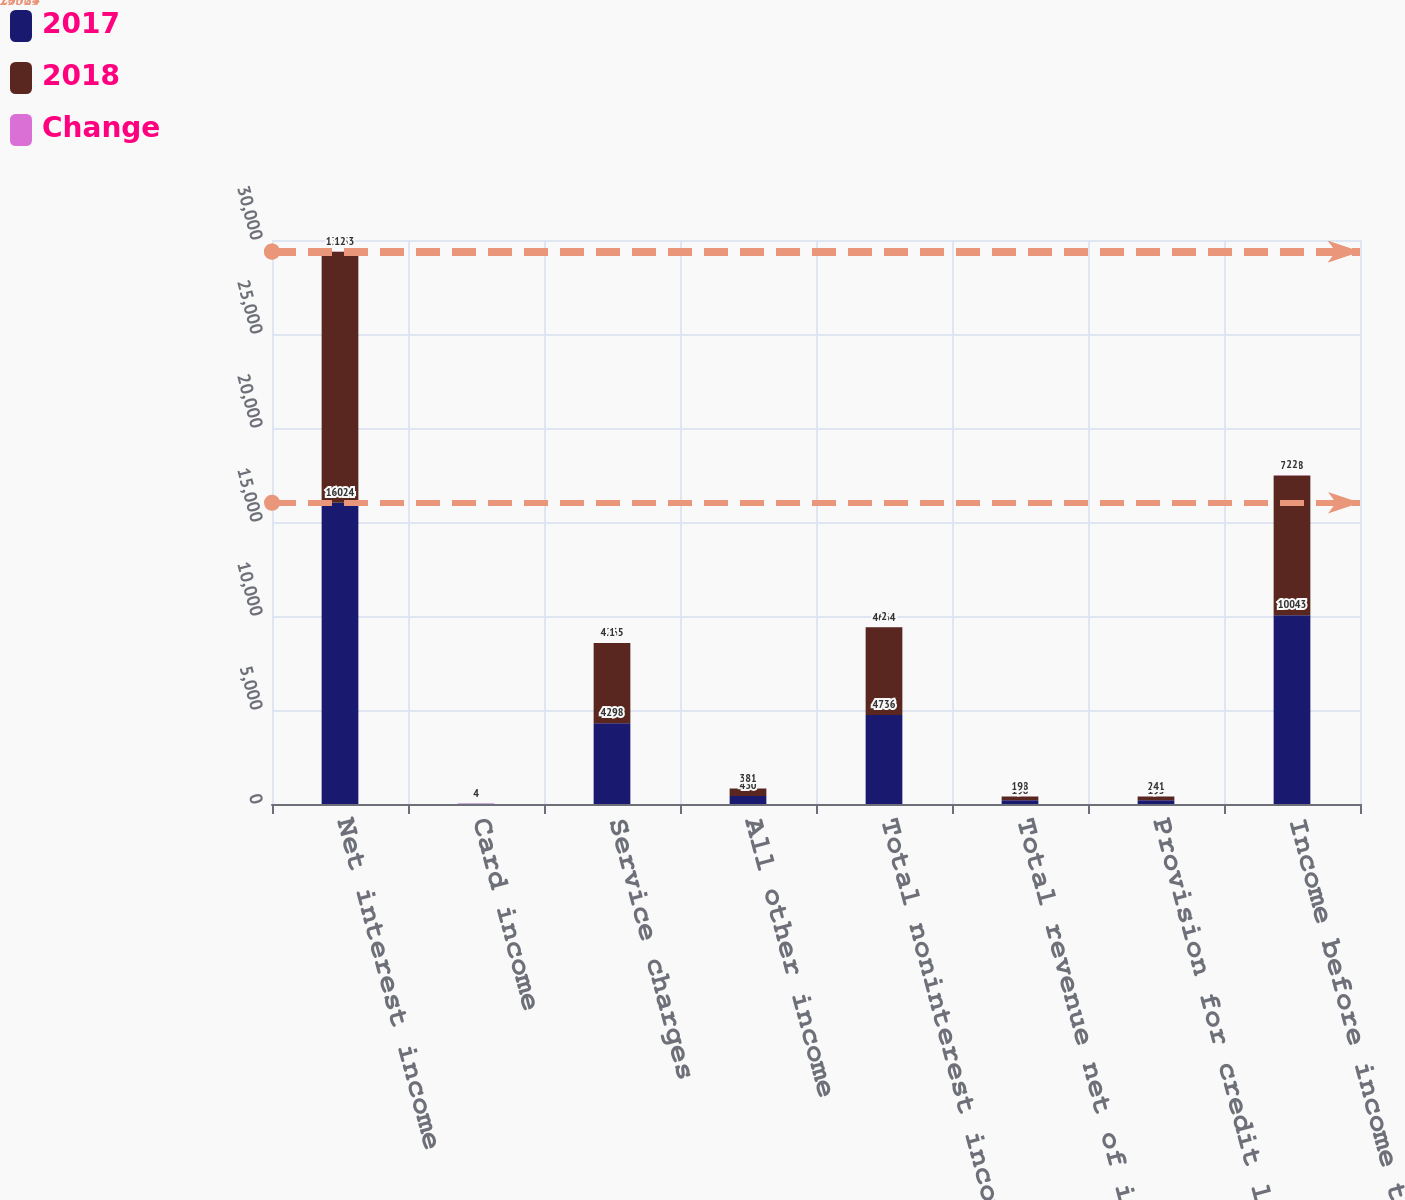<chart> <loc_0><loc_0><loc_500><loc_500><stacked_bar_chart><ecel><fcel>Net interest income<fcel>Card income<fcel>Service charges<fcel>All other income<fcel>Total noninterest income<fcel>Total revenue net of interest<fcel>Provision for credit losses<fcel>Income before income taxes<nl><fcel>2017<fcel>16024<fcel>8<fcel>4298<fcel>430<fcel>4736<fcel>198<fcel>195<fcel>10043<nl><fcel>2018<fcel>13353<fcel>8<fcel>4265<fcel>391<fcel>4664<fcel>198<fcel>201<fcel>7428<nl><fcel>Change<fcel>12<fcel>4<fcel>1<fcel>8<fcel>2<fcel>9<fcel>4<fcel>22<nl></chart> 